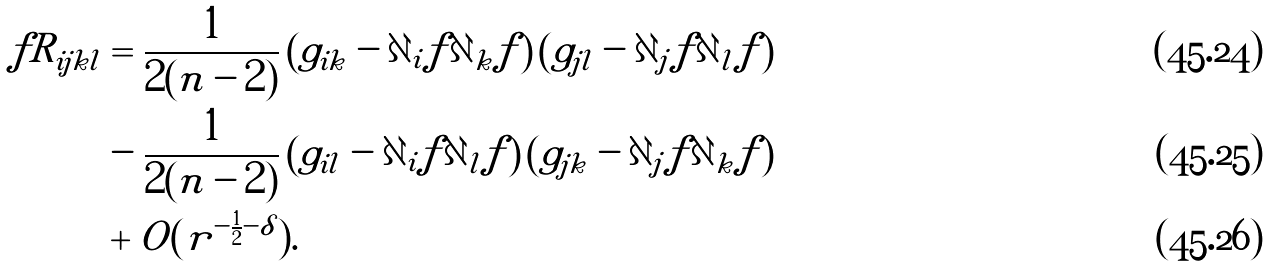<formula> <loc_0><loc_0><loc_500><loc_500>f R _ { i j k l } & = \frac { 1 } { 2 ( n - 2 ) } \left ( g _ { i k } - \partial _ { i } f \partial _ { k } f \right ) \left ( g _ { j l } - \partial _ { j } f \partial _ { l } f \right ) \\ & - \frac { 1 } { 2 ( n - 2 ) } \left ( g _ { i l } - \partial _ { i } f \partial _ { l } f \right ) \left ( g _ { j k } - \partial _ { j } f \partial _ { k } f \right ) \\ & + O ( r ^ { - \frac { 1 } { 2 } - \delta } ) .</formula> 